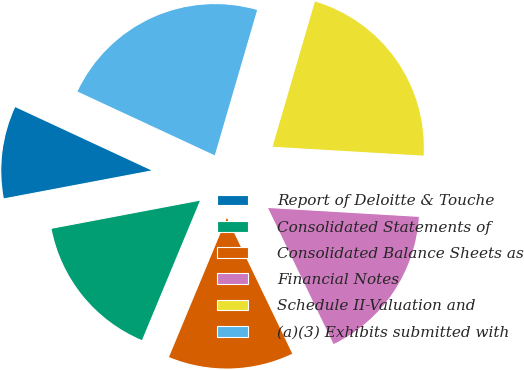Convert chart to OTSL. <chart><loc_0><loc_0><loc_500><loc_500><pie_chart><fcel>Report of Deloitte & Touche<fcel>Consolidated Statements of<fcel>Consolidated Balance Sheets as<fcel>Financial Notes<fcel>Schedule II-Valuation and<fcel>(a)(3) Exhibits submitted with<nl><fcel>9.9%<fcel>15.75%<fcel>13.41%<fcel>16.92%<fcel>21.42%<fcel>22.59%<nl></chart> 